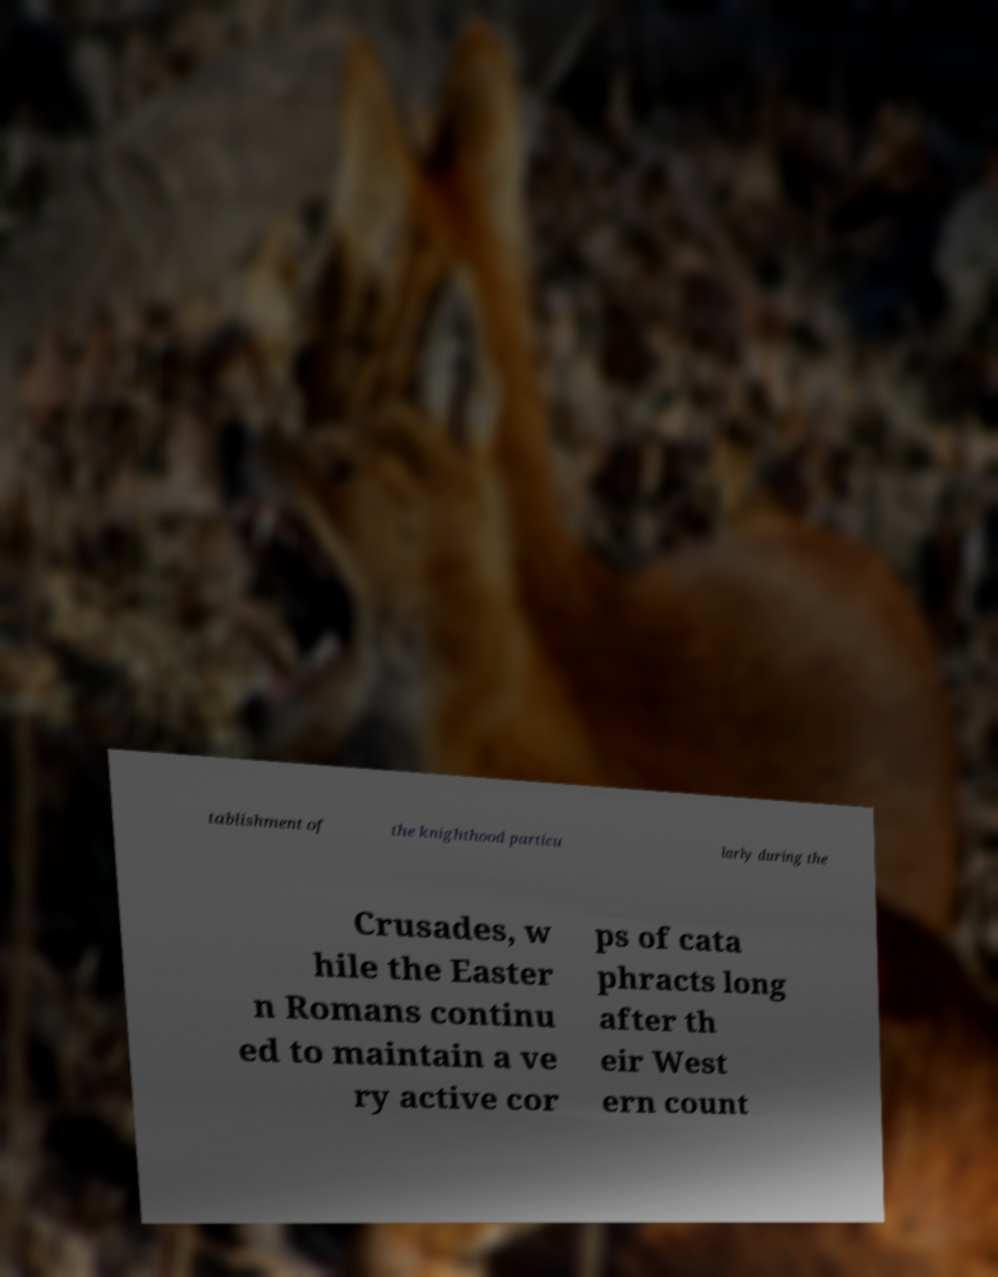What messages or text are displayed in this image? I need them in a readable, typed format. tablishment of the knighthood particu larly during the Crusades, w hile the Easter n Romans continu ed to maintain a ve ry active cor ps of cata phracts long after th eir West ern count 